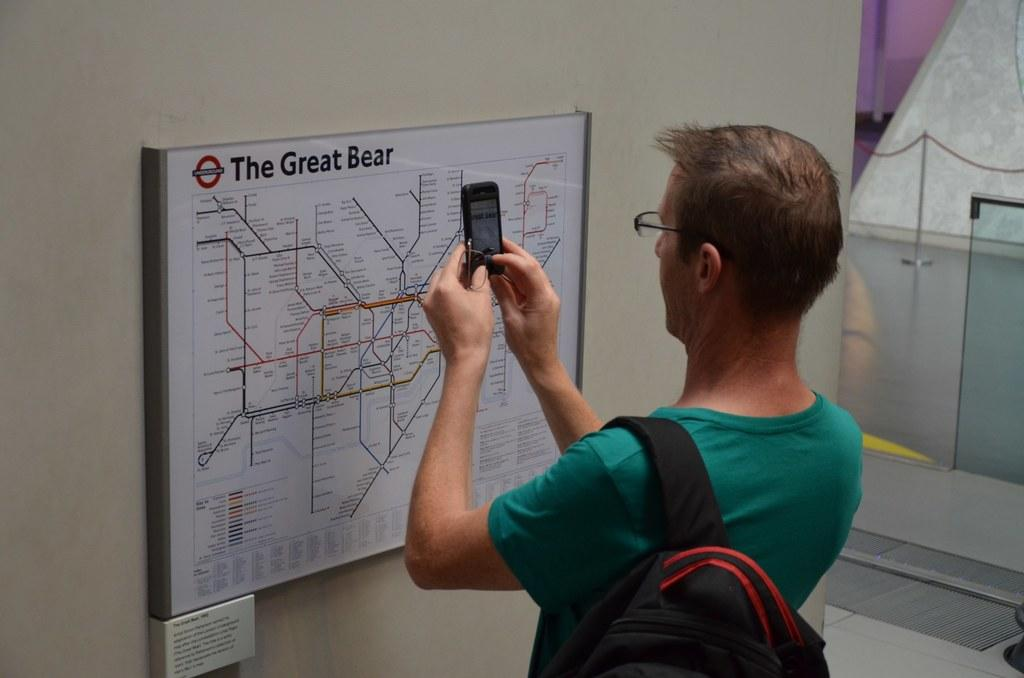<image>
Offer a succinct explanation of the picture presented. A man taking a photo of a bus route map called The Great Bear. 